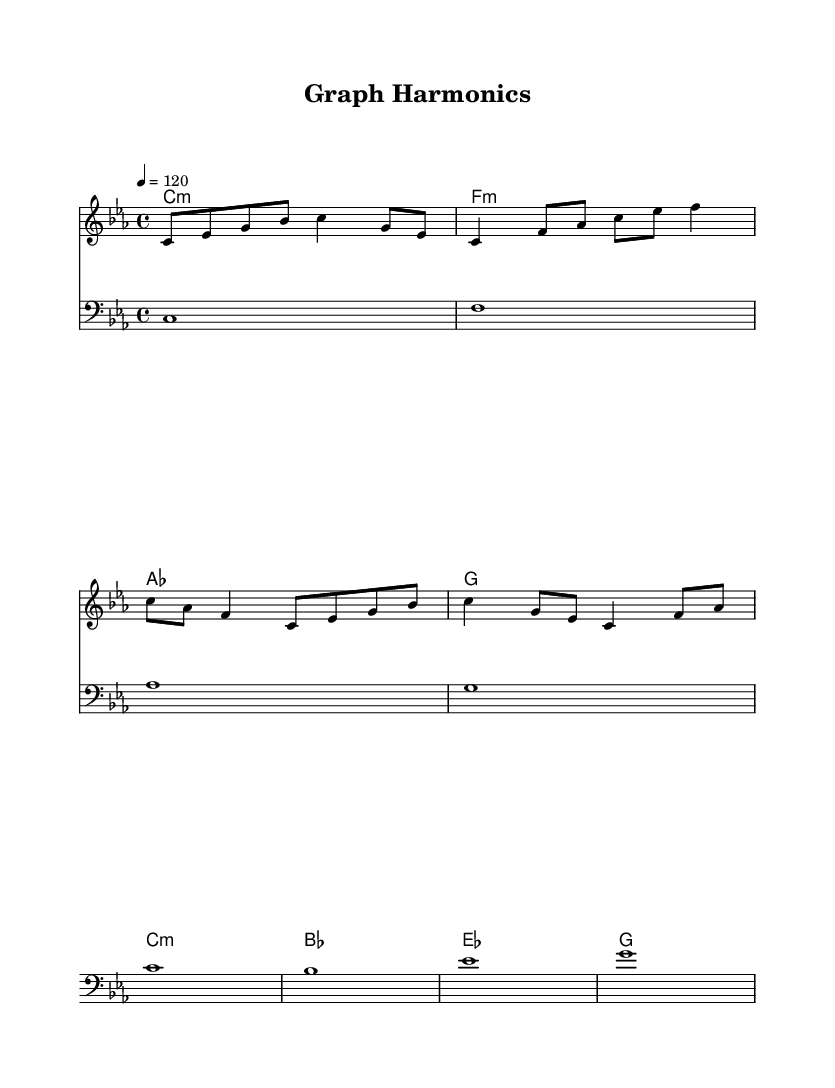What is the key signature of this music? The key signature is indicated by the absence of sharps or flats at the beginning of the staff, which corresponds to the key of C minor.
Answer: C minor What is the time signature of this music? The time signature is indicated by the numbers at the beginning of the score, which shows four beats in a measure.
Answer: 4/4 What is the tempo marking given in this music? The tempo marking is indicated by the number 120 at the beginning of the piece, suggesting the quarter note gets one beat at a tempo of 120 beats per minute.
Answer: 120 How many measures are in the melody? To find the number of measures, we need to count each segment separated by vertical lines in the melody. The melody consists of four measures.
Answer: 4 Which chord appears most frequently in the harmony section? We check the chord progression in the harmony section, which includes C minor (c:m), F minor (f:m), A flat (as), and G (g). The C minor chord appears in the first and fifth measures, making it the most frequent.
Answer: C minor What type of composition is this piece classified as? The title "Graph Harmonics" suggests that this piece is inspired by concepts from graph theory and algorithmic compositions, highlighting its electronic music style.
Answer: Electronic music 